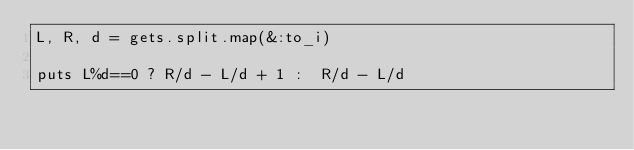Convert code to text. <code><loc_0><loc_0><loc_500><loc_500><_Ruby_>L, R, d = gets.split.map(&:to_i)

puts L%d==0 ? R/d - L/d + 1 :  R/d - L/d

</code> 